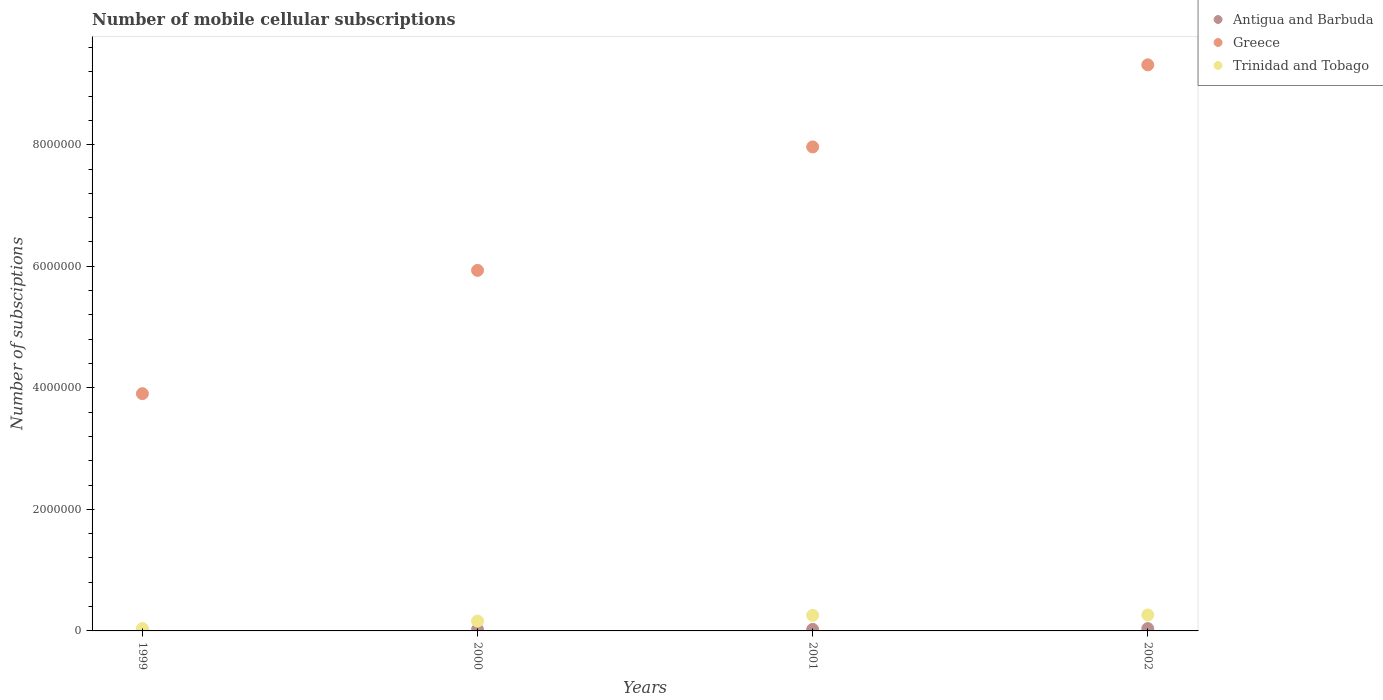How many different coloured dotlines are there?
Ensure brevity in your answer.  3. Is the number of dotlines equal to the number of legend labels?
Provide a succinct answer. Yes. What is the number of mobile cellular subscriptions in Greece in 2001?
Your response must be concise. 7.96e+06. Across all years, what is the maximum number of mobile cellular subscriptions in Antigua and Barbuda?
Make the answer very short. 3.82e+04. Across all years, what is the minimum number of mobile cellular subscriptions in Antigua and Barbuda?
Provide a short and direct response. 8500. In which year was the number of mobile cellular subscriptions in Antigua and Barbuda maximum?
Provide a short and direct response. 2002. In which year was the number of mobile cellular subscriptions in Antigua and Barbuda minimum?
Your response must be concise. 1999. What is the total number of mobile cellular subscriptions in Antigua and Barbuda in the graph?
Your answer should be very brief. 9.37e+04. What is the difference between the number of mobile cellular subscriptions in Trinidad and Tobago in 2001 and that in 2002?
Offer a terse response. -6666. What is the difference between the number of mobile cellular subscriptions in Trinidad and Tobago in 1999 and the number of mobile cellular subscriptions in Antigua and Barbuda in 2001?
Your answer should be very brief. 1.37e+04. What is the average number of mobile cellular subscriptions in Antigua and Barbuda per year?
Offer a terse response. 2.34e+04. In the year 2000, what is the difference between the number of mobile cellular subscriptions in Greece and number of mobile cellular subscriptions in Trinidad and Tobago?
Your answer should be very brief. 5.77e+06. What is the ratio of the number of mobile cellular subscriptions in Antigua and Barbuda in 1999 to that in 2000?
Your answer should be compact. 0.39. Is the number of mobile cellular subscriptions in Greece in 1999 less than that in 2001?
Provide a short and direct response. Yes. Is the difference between the number of mobile cellular subscriptions in Greece in 1999 and 2002 greater than the difference between the number of mobile cellular subscriptions in Trinidad and Tobago in 1999 and 2002?
Make the answer very short. No. What is the difference between the highest and the second highest number of mobile cellular subscriptions in Greece?
Provide a short and direct response. 1.35e+06. What is the difference between the highest and the lowest number of mobile cellular subscriptions in Greece?
Your response must be concise. 5.41e+06. In how many years, is the number of mobile cellular subscriptions in Greece greater than the average number of mobile cellular subscriptions in Greece taken over all years?
Give a very brief answer. 2. Is the sum of the number of mobile cellular subscriptions in Antigua and Barbuda in 2000 and 2002 greater than the maximum number of mobile cellular subscriptions in Trinidad and Tobago across all years?
Provide a short and direct response. No. Does the number of mobile cellular subscriptions in Trinidad and Tobago monotonically increase over the years?
Ensure brevity in your answer.  Yes. How many years are there in the graph?
Give a very brief answer. 4. What is the title of the graph?
Your response must be concise. Number of mobile cellular subscriptions. What is the label or title of the X-axis?
Give a very brief answer. Years. What is the label or title of the Y-axis?
Offer a very short reply. Number of subsciptions. What is the Number of subsciptions of Antigua and Barbuda in 1999?
Make the answer very short. 8500. What is the Number of subsciptions in Greece in 1999?
Your response must be concise. 3.90e+06. What is the Number of subsciptions of Trinidad and Tobago in 1999?
Ensure brevity in your answer.  3.87e+04. What is the Number of subsciptions in Antigua and Barbuda in 2000?
Your answer should be compact. 2.20e+04. What is the Number of subsciptions of Greece in 2000?
Offer a very short reply. 5.93e+06. What is the Number of subsciptions of Trinidad and Tobago in 2000?
Provide a succinct answer. 1.62e+05. What is the Number of subsciptions in Antigua and Barbuda in 2001?
Offer a very short reply. 2.50e+04. What is the Number of subsciptions in Greece in 2001?
Your response must be concise. 7.96e+06. What is the Number of subsciptions of Trinidad and Tobago in 2001?
Your answer should be compact. 2.56e+05. What is the Number of subsciptions of Antigua and Barbuda in 2002?
Ensure brevity in your answer.  3.82e+04. What is the Number of subsciptions in Greece in 2002?
Your response must be concise. 9.31e+06. What is the Number of subsciptions in Trinidad and Tobago in 2002?
Give a very brief answer. 2.63e+05. Across all years, what is the maximum Number of subsciptions in Antigua and Barbuda?
Offer a terse response. 3.82e+04. Across all years, what is the maximum Number of subsciptions in Greece?
Ensure brevity in your answer.  9.31e+06. Across all years, what is the maximum Number of subsciptions in Trinidad and Tobago?
Provide a short and direct response. 2.63e+05. Across all years, what is the minimum Number of subsciptions of Antigua and Barbuda?
Provide a succinct answer. 8500. Across all years, what is the minimum Number of subsciptions of Greece?
Give a very brief answer. 3.90e+06. Across all years, what is the minimum Number of subsciptions in Trinidad and Tobago?
Your response must be concise. 3.87e+04. What is the total Number of subsciptions in Antigua and Barbuda in the graph?
Your answer should be very brief. 9.37e+04. What is the total Number of subsciptions of Greece in the graph?
Keep it short and to the point. 2.71e+07. What is the total Number of subsciptions in Trinidad and Tobago in the graph?
Offer a terse response. 7.19e+05. What is the difference between the Number of subsciptions in Antigua and Barbuda in 1999 and that in 2000?
Keep it short and to the point. -1.35e+04. What is the difference between the Number of subsciptions in Greece in 1999 and that in 2000?
Offer a terse response. -2.03e+06. What is the difference between the Number of subsciptions of Trinidad and Tobago in 1999 and that in 2000?
Ensure brevity in your answer.  -1.23e+05. What is the difference between the Number of subsciptions in Antigua and Barbuda in 1999 and that in 2001?
Your answer should be compact. -1.65e+04. What is the difference between the Number of subsciptions of Greece in 1999 and that in 2001?
Give a very brief answer. -4.06e+06. What is the difference between the Number of subsciptions of Trinidad and Tobago in 1999 and that in 2001?
Keep it short and to the point. -2.17e+05. What is the difference between the Number of subsciptions in Antigua and Barbuda in 1999 and that in 2002?
Your response must be concise. -2.97e+04. What is the difference between the Number of subsciptions in Greece in 1999 and that in 2002?
Provide a short and direct response. -5.41e+06. What is the difference between the Number of subsciptions of Trinidad and Tobago in 1999 and that in 2002?
Ensure brevity in your answer.  -2.24e+05. What is the difference between the Number of subsciptions of Antigua and Barbuda in 2000 and that in 2001?
Offer a terse response. -3000. What is the difference between the Number of subsciptions of Greece in 2000 and that in 2001?
Make the answer very short. -2.03e+06. What is the difference between the Number of subsciptions of Trinidad and Tobago in 2000 and that in 2001?
Offer a very short reply. -9.42e+04. What is the difference between the Number of subsciptions of Antigua and Barbuda in 2000 and that in 2002?
Ensure brevity in your answer.  -1.62e+04. What is the difference between the Number of subsciptions of Greece in 2000 and that in 2002?
Offer a terse response. -3.38e+06. What is the difference between the Number of subsciptions in Trinidad and Tobago in 2000 and that in 2002?
Offer a terse response. -1.01e+05. What is the difference between the Number of subsciptions in Antigua and Barbuda in 2001 and that in 2002?
Make the answer very short. -1.32e+04. What is the difference between the Number of subsciptions in Greece in 2001 and that in 2002?
Give a very brief answer. -1.35e+06. What is the difference between the Number of subsciptions in Trinidad and Tobago in 2001 and that in 2002?
Offer a very short reply. -6666. What is the difference between the Number of subsciptions in Antigua and Barbuda in 1999 and the Number of subsciptions in Greece in 2000?
Ensure brevity in your answer.  -5.92e+06. What is the difference between the Number of subsciptions of Antigua and Barbuda in 1999 and the Number of subsciptions of Trinidad and Tobago in 2000?
Give a very brief answer. -1.53e+05. What is the difference between the Number of subsciptions of Greece in 1999 and the Number of subsciptions of Trinidad and Tobago in 2000?
Provide a short and direct response. 3.74e+06. What is the difference between the Number of subsciptions in Antigua and Barbuda in 1999 and the Number of subsciptions in Greece in 2001?
Provide a succinct answer. -7.96e+06. What is the difference between the Number of subsciptions in Antigua and Barbuda in 1999 and the Number of subsciptions in Trinidad and Tobago in 2001?
Your answer should be compact. -2.48e+05. What is the difference between the Number of subsciptions of Greece in 1999 and the Number of subsciptions of Trinidad and Tobago in 2001?
Provide a succinct answer. 3.65e+06. What is the difference between the Number of subsciptions of Antigua and Barbuda in 1999 and the Number of subsciptions of Greece in 2002?
Provide a short and direct response. -9.31e+06. What is the difference between the Number of subsciptions in Antigua and Barbuda in 1999 and the Number of subsciptions in Trinidad and Tobago in 2002?
Your answer should be very brief. -2.54e+05. What is the difference between the Number of subsciptions of Greece in 1999 and the Number of subsciptions of Trinidad and Tobago in 2002?
Keep it short and to the point. 3.64e+06. What is the difference between the Number of subsciptions of Antigua and Barbuda in 2000 and the Number of subsciptions of Greece in 2001?
Your answer should be very brief. -7.94e+06. What is the difference between the Number of subsciptions of Antigua and Barbuda in 2000 and the Number of subsciptions of Trinidad and Tobago in 2001?
Your response must be concise. -2.34e+05. What is the difference between the Number of subsciptions of Greece in 2000 and the Number of subsciptions of Trinidad and Tobago in 2001?
Make the answer very short. 5.68e+06. What is the difference between the Number of subsciptions in Antigua and Barbuda in 2000 and the Number of subsciptions in Greece in 2002?
Keep it short and to the point. -9.29e+06. What is the difference between the Number of subsciptions in Antigua and Barbuda in 2000 and the Number of subsciptions in Trinidad and Tobago in 2002?
Your answer should be compact. -2.41e+05. What is the difference between the Number of subsciptions of Greece in 2000 and the Number of subsciptions of Trinidad and Tobago in 2002?
Your answer should be very brief. 5.67e+06. What is the difference between the Number of subsciptions of Antigua and Barbuda in 2001 and the Number of subsciptions of Greece in 2002?
Your answer should be compact. -9.29e+06. What is the difference between the Number of subsciptions of Antigua and Barbuda in 2001 and the Number of subsciptions of Trinidad and Tobago in 2002?
Your answer should be compact. -2.38e+05. What is the difference between the Number of subsciptions in Greece in 2001 and the Number of subsciptions in Trinidad and Tobago in 2002?
Offer a very short reply. 7.70e+06. What is the average Number of subsciptions of Antigua and Barbuda per year?
Your answer should be very brief. 2.34e+04. What is the average Number of subsciptions of Greece per year?
Your answer should be compact. 6.78e+06. What is the average Number of subsciptions in Trinidad and Tobago per year?
Make the answer very short. 1.80e+05. In the year 1999, what is the difference between the Number of subsciptions in Antigua and Barbuda and Number of subsciptions in Greece?
Make the answer very short. -3.90e+06. In the year 1999, what is the difference between the Number of subsciptions in Antigua and Barbuda and Number of subsciptions in Trinidad and Tobago?
Make the answer very short. -3.02e+04. In the year 1999, what is the difference between the Number of subsciptions of Greece and Number of subsciptions of Trinidad and Tobago?
Make the answer very short. 3.87e+06. In the year 2000, what is the difference between the Number of subsciptions in Antigua and Barbuda and Number of subsciptions in Greece?
Your answer should be compact. -5.91e+06. In the year 2000, what is the difference between the Number of subsciptions of Antigua and Barbuda and Number of subsciptions of Trinidad and Tobago?
Make the answer very short. -1.40e+05. In the year 2000, what is the difference between the Number of subsciptions of Greece and Number of subsciptions of Trinidad and Tobago?
Keep it short and to the point. 5.77e+06. In the year 2001, what is the difference between the Number of subsciptions in Antigua and Barbuda and Number of subsciptions in Greece?
Offer a terse response. -7.94e+06. In the year 2001, what is the difference between the Number of subsciptions of Antigua and Barbuda and Number of subsciptions of Trinidad and Tobago?
Make the answer very short. -2.31e+05. In the year 2001, what is the difference between the Number of subsciptions in Greece and Number of subsciptions in Trinidad and Tobago?
Your answer should be compact. 7.71e+06. In the year 2002, what is the difference between the Number of subsciptions in Antigua and Barbuda and Number of subsciptions in Greece?
Your answer should be very brief. -9.28e+06. In the year 2002, what is the difference between the Number of subsciptions in Antigua and Barbuda and Number of subsciptions in Trinidad and Tobago?
Your answer should be very brief. -2.25e+05. In the year 2002, what is the difference between the Number of subsciptions in Greece and Number of subsciptions in Trinidad and Tobago?
Keep it short and to the point. 9.05e+06. What is the ratio of the Number of subsciptions of Antigua and Barbuda in 1999 to that in 2000?
Give a very brief answer. 0.39. What is the ratio of the Number of subsciptions of Greece in 1999 to that in 2000?
Keep it short and to the point. 0.66. What is the ratio of the Number of subsciptions of Trinidad and Tobago in 1999 to that in 2000?
Offer a very short reply. 0.24. What is the ratio of the Number of subsciptions in Antigua and Barbuda in 1999 to that in 2001?
Give a very brief answer. 0.34. What is the ratio of the Number of subsciptions of Greece in 1999 to that in 2001?
Provide a succinct answer. 0.49. What is the ratio of the Number of subsciptions of Trinidad and Tobago in 1999 to that in 2001?
Give a very brief answer. 0.15. What is the ratio of the Number of subsciptions in Antigua and Barbuda in 1999 to that in 2002?
Your answer should be very brief. 0.22. What is the ratio of the Number of subsciptions of Greece in 1999 to that in 2002?
Keep it short and to the point. 0.42. What is the ratio of the Number of subsciptions in Trinidad and Tobago in 1999 to that in 2002?
Your answer should be compact. 0.15. What is the ratio of the Number of subsciptions in Antigua and Barbuda in 2000 to that in 2001?
Offer a very short reply. 0.88. What is the ratio of the Number of subsciptions of Greece in 2000 to that in 2001?
Your answer should be very brief. 0.74. What is the ratio of the Number of subsciptions of Trinidad and Tobago in 2000 to that in 2001?
Keep it short and to the point. 0.63. What is the ratio of the Number of subsciptions of Antigua and Barbuda in 2000 to that in 2002?
Ensure brevity in your answer.  0.58. What is the ratio of the Number of subsciptions of Greece in 2000 to that in 2002?
Your response must be concise. 0.64. What is the ratio of the Number of subsciptions in Trinidad and Tobago in 2000 to that in 2002?
Make the answer very short. 0.62. What is the ratio of the Number of subsciptions in Antigua and Barbuda in 2001 to that in 2002?
Your answer should be very brief. 0.65. What is the ratio of the Number of subsciptions of Greece in 2001 to that in 2002?
Your response must be concise. 0.85. What is the ratio of the Number of subsciptions of Trinidad and Tobago in 2001 to that in 2002?
Your answer should be compact. 0.97. What is the difference between the highest and the second highest Number of subsciptions of Antigua and Barbuda?
Give a very brief answer. 1.32e+04. What is the difference between the highest and the second highest Number of subsciptions in Greece?
Offer a terse response. 1.35e+06. What is the difference between the highest and the second highest Number of subsciptions of Trinidad and Tobago?
Your answer should be compact. 6666. What is the difference between the highest and the lowest Number of subsciptions of Antigua and Barbuda?
Ensure brevity in your answer.  2.97e+04. What is the difference between the highest and the lowest Number of subsciptions of Greece?
Offer a very short reply. 5.41e+06. What is the difference between the highest and the lowest Number of subsciptions in Trinidad and Tobago?
Offer a very short reply. 2.24e+05. 